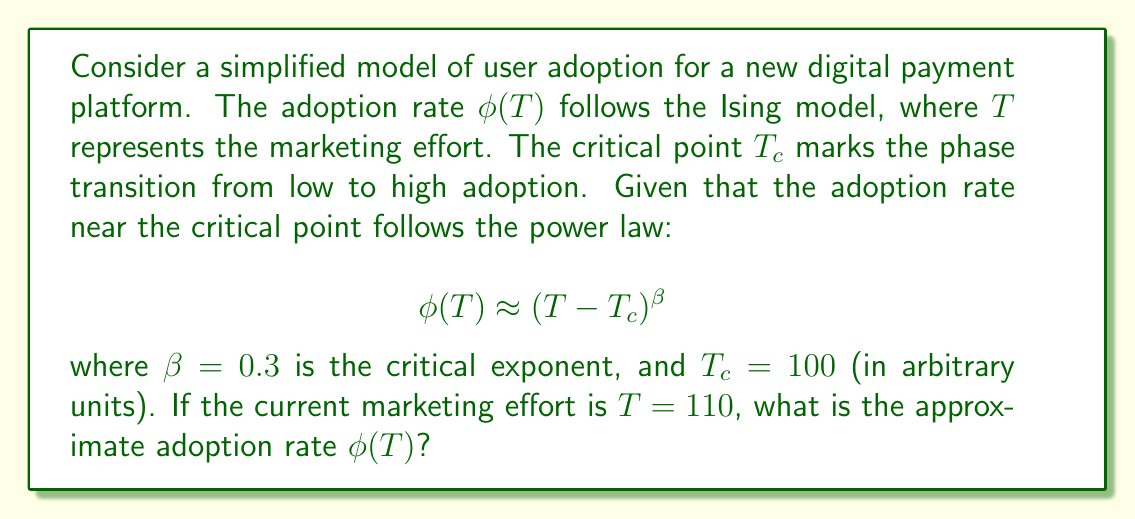Solve this math problem. To solve this problem, we'll follow these steps:

1) We are given the power law equation for the adoption rate near the critical point:
   $$\phi(T) \approx (T - T_c)^\beta$$

2) We know the following values:
   - Critical exponent $\beta = 0.3$
   - Critical point $T_c = 100$
   - Current marketing effort $T = 110$

3) Let's substitute these values into the equation:
   $$\phi(110) \approx (110 - 100)^{0.3}$$

4) Simplify inside the parentheses:
   $$\phi(110) \approx (10)^{0.3}$$

5) Calculate the power:
   $$\phi(110) \approx 10^{0.3} \approx 1.995262315$$

6) Round to three decimal places for a reasonable approximation:
   $$\phi(110) \approx 1.995$$

Therefore, the approximate adoption rate at $T = 110$ is 1.995 or about 199.5%.
Answer: $\phi(110) \approx 1.995$ 